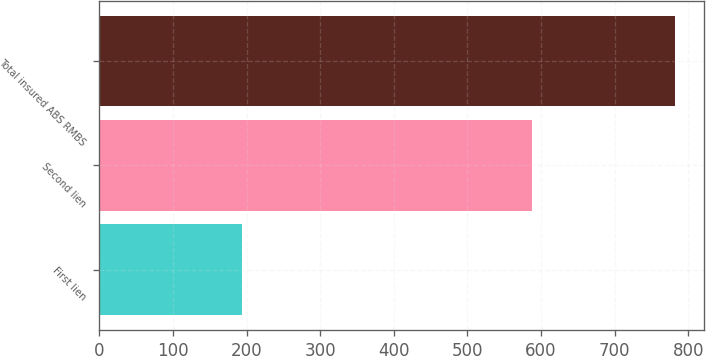Convert chart. <chart><loc_0><loc_0><loc_500><loc_500><bar_chart><fcel>First lien<fcel>Second lien<fcel>Total insured ABS RMBS<nl><fcel>194<fcel>588<fcel>782<nl></chart> 